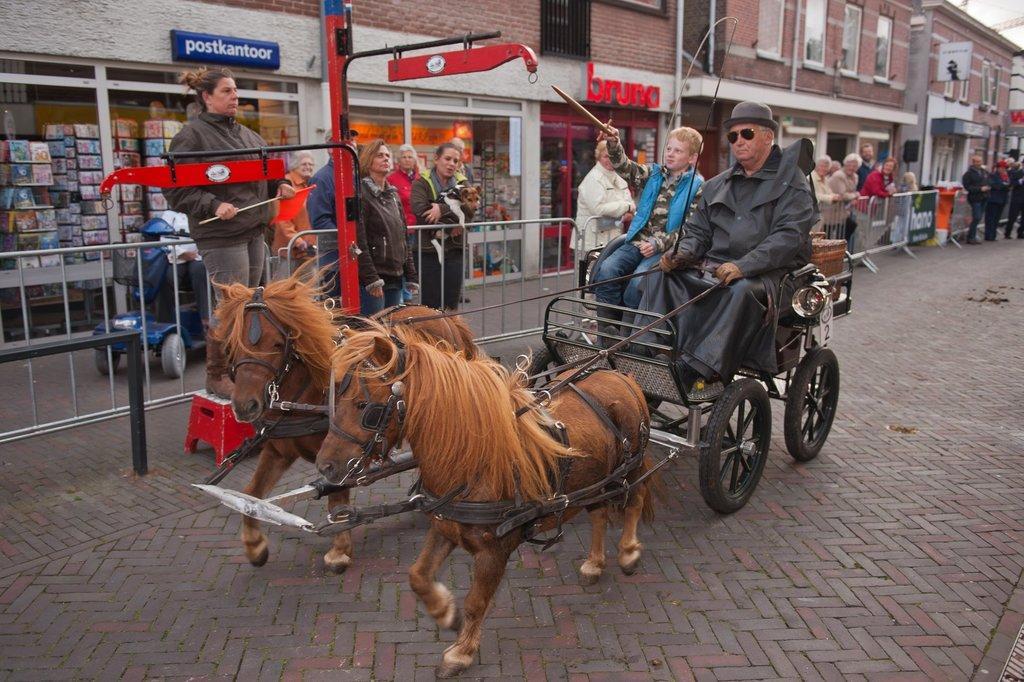Could you give a brief overview of what you see in this image? In this image, in the middle, we can see two people, one person is holding a stick in his hand and another person is sitting on the cart of a horse and holding a collar rope of a horse. In the background, we can see a group of people standing in front of the metal grill. In the background, we can also see a metal rod, metal pole, building, glass window, hoarding. At the bottom, we can see a road. 